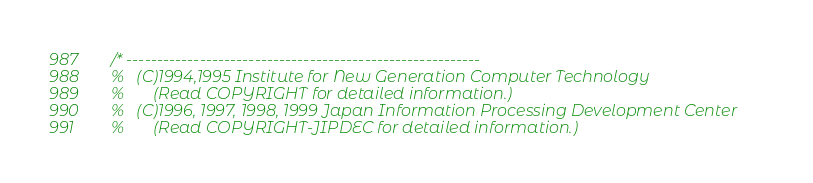<code> <loc_0><loc_0><loc_500><loc_500><_C_>/* ---------------------------------------------------------- 
%   (C)1994,1995 Institute for New Generation Computer Technology 
%       (Read COPYRIGHT for detailed information.) 
%   (C)1996, 1997, 1998, 1999 Japan Information Processing Development Center
%       (Read COPYRIGHT-JIPDEC for detailed information.)</code> 